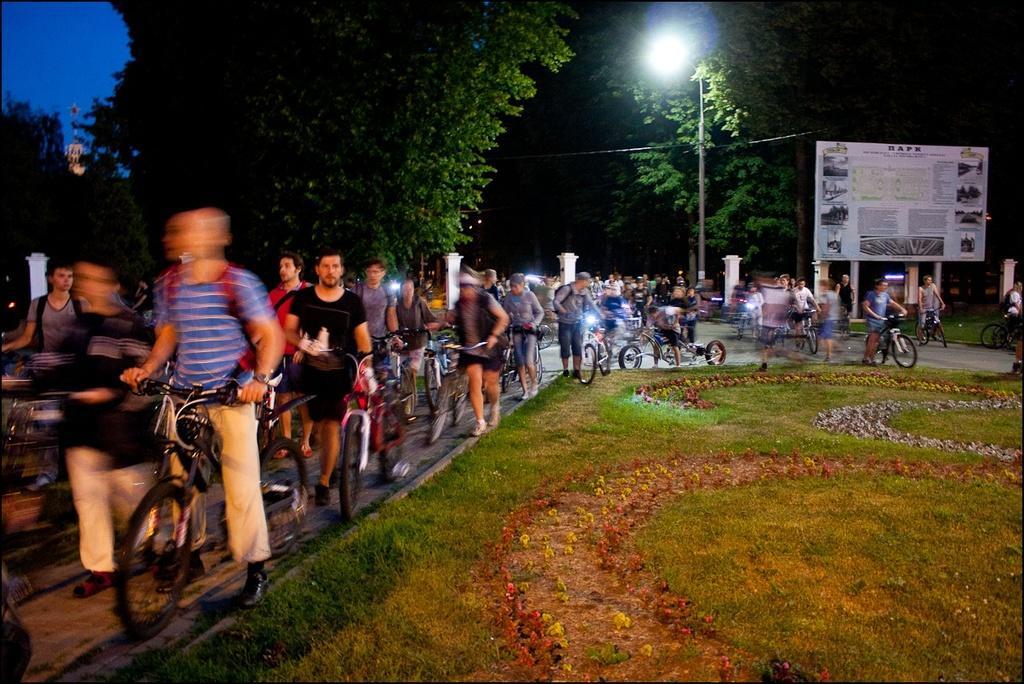Can you describe this image briefly? In the image we can see there are many people, wearing clothes and shoes. Few people are riding on the bicycle and some of them are holding it. There is a grass, trees, pole, electric wire, light, board, pillars and a blue sky. 